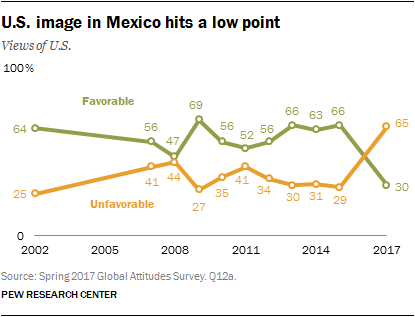What is the difference between Unfavorable and the Favorable in the year 2017? In the year 2017, according to the graph, the percentage of people in Mexico with a favorable view of the U.S. was 65%, whereas the percentage with an unfavorable view was 30%. This indicates a difference of 35 percentage points between the favorable and unfavorable views. 